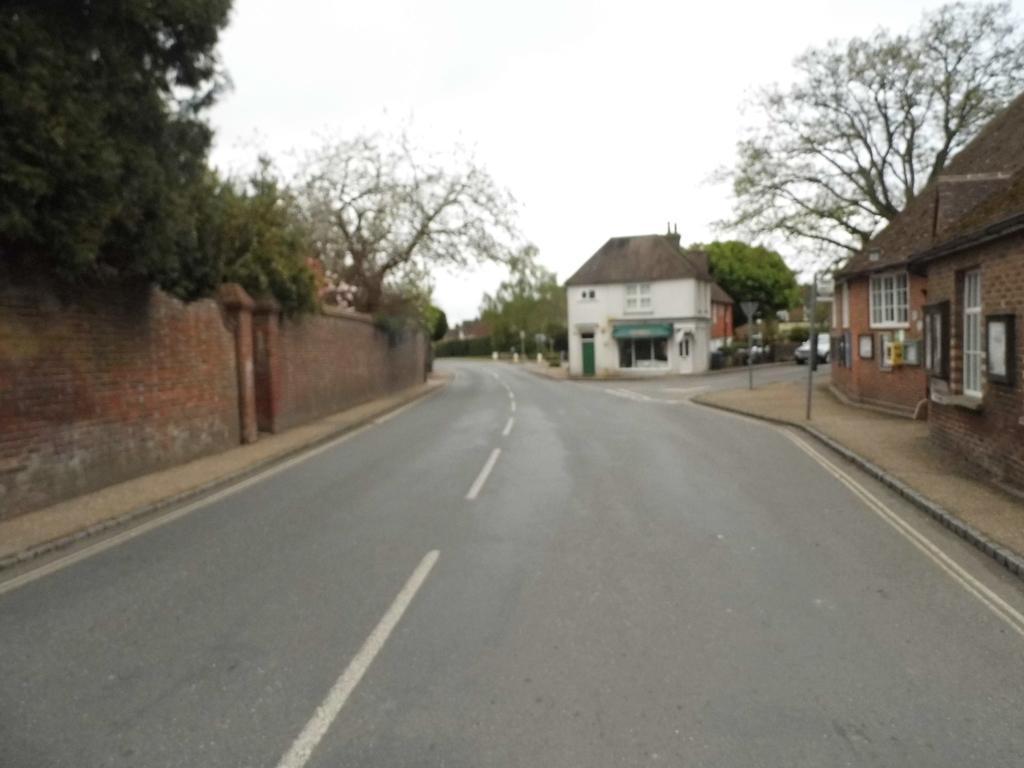Can you describe this image briefly? In this image there is road, compound wall, plants, poles, buildings, trees, car, sky. 